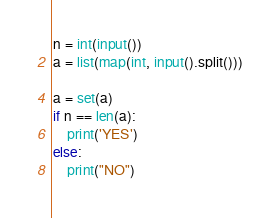<code> <loc_0><loc_0><loc_500><loc_500><_Python_>n = int(input())
a = list(map(int, input().split()))

a = set(a)
if n == len(a):
    print('YES')
else:
    print("NO")
</code> 